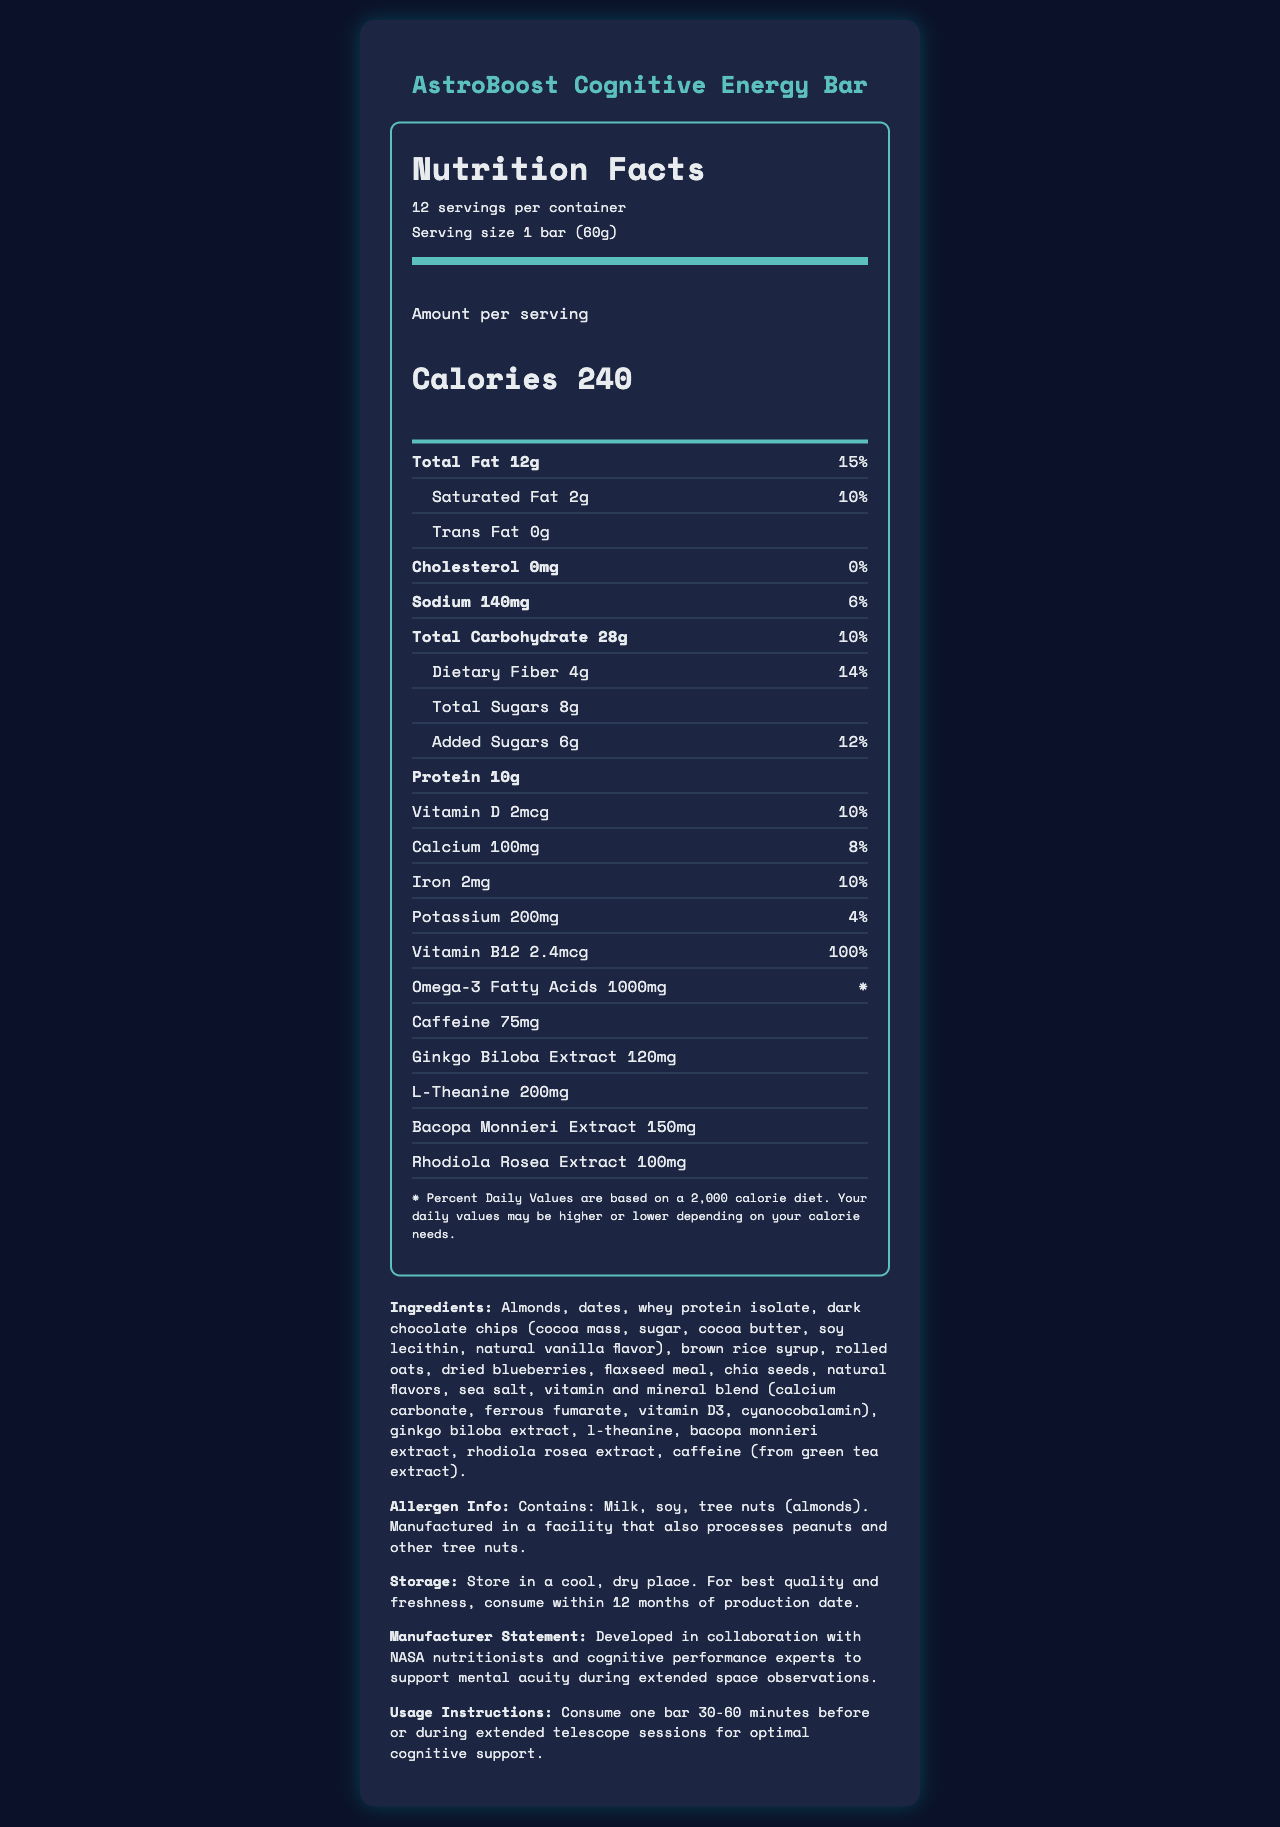What is the serving size for the AstroBoost Cognitive Energy Bar? The serving size is clearly indicated in the Nutrition Facts section of the document.
Answer: 1 bar (60g) How many servings are in one container of the AstroBoost Cognitive Energy Bar? The document mentions that there are 12 servings per container.
Answer: 12 What percentage of the Daily Value for Vitamin B12 does one serving of the energy bar provide? The nutrition label specifies that one serving provides 100% of the Daily Value for Vitamin B12.
Answer: 100% How much protein is in one serving of the energy bar? The document states that one serving of the energy bar contains 10g of protein.
Answer: 10g Is there any cholesterol in the AstroBoost Cognitive Energy Bar? The nutrition label indicates that the cholesterol content is 0mg, which means there is no cholesterol in the bar.
Answer: No What are the ingredients used in the AstroBoost Cognitive Energy Bar? (Choose all that apply) 
A. Almonds 
B. Dates 
C. Brown rice syrup 
D. Almond extract The ingredients section mentions almonds, dates, and brown rice syrup. Almond extract is not listed.
Answer: A, B, C How much sodium is in one serving of the energy bar? 
A. 100mg 
B. 120mg 
C. 140mg 
D. 160mg The document states that the sodium content per serving is 140mg.
Answer: C Can this product be safely consumed by someone with a tree nut allergy? The allergen info indicates that the bar contains tree nuts (almonds).
Answer: No Was the AstroBoost Cognitive Energy Bar developed in collaboration with NASA nutritionists? The manufacturer statement mentions collaboration with NASA nutritionists.
Answer: Yes Summarize the main idea of the AstroBoost Cognitive Energy Bar's Nutrition Facts Label. This summary encapsulates the key points such as nutritional content, specific ingredients for cognitive support, and the unique collaboration with NASA.
Answer: The AstroBoost Cognitive Energy Bar is designed to boost cognitive function during space observations. Each 60g bar contains 240 calories, 12g total fat, 10g protein, and various vitamins and minerals like Vitamin B12 (100% DV) and Iron (10% DV). It includes cognitive enhancers like caffeine, ginkgo biloba extract, and l-theanine. The product highlights its natural ingredients and safe consumption instructions, along with allergen information, storing guidelines, and usage instructions for optimal cognitive support. What is the amount of added sugars in a single serving of the energy bar? The document specifies that there are 6g of added sugars per serving.
Answer: 6g Is the daily value percentage for calcium higher than that for potassium? The daily value for calcium is 8%, while for potassium it is 4%.
Answer: Yes Does the energy bar contain trans fat? The nutrition label shows that the trans fat content is 0g.
Answer: No Who developed the AstroBoost Cognitive Energy Bar? The manufacturer's statement mentions this collaboration explicitly.
Answer: Developed in collaboration with NASA nutritionists and cognitive performance experts What is the recommended time to consume the energy bar for optimal cognitive support? This information is provided in the usage instructions section of the document.
Answer: 30-60 minutes before or during extended telescope sessions Does the energy bar contain any caffeine? The nutrition label lists caffeine content as 75mg per serving.
Answer: Yes Is the calcium content in one serving of the energy bar more than 100mg? The document specifies that there is 100mg of calcium per serving, which is equal to 8% DV but not more.
Answer: Yes How much omega-3 fatty acids does one serving of the energy bar provide? The nutrition label indicates a content of 1000mg of omega-3 fatty acids per serving.
Answer: 1000mg What is the total fat percentage of the Daily Value for one serving? The document mentions the total fat is 12g, which corresponds to 15% of the Daily Value.
Answer: 15% How long does the product remain fresh? The storage instructions section advises consuming within 12 months for best quality and freshness.
Answer: 12 months from the production date Are the daily values based on a 1,500 calorie diet? The disclaimer states that the Percent Daily Values are based on a 2,000 calorie diet; it does not mention 1,500 calories.
Answer: Cannot be determined 